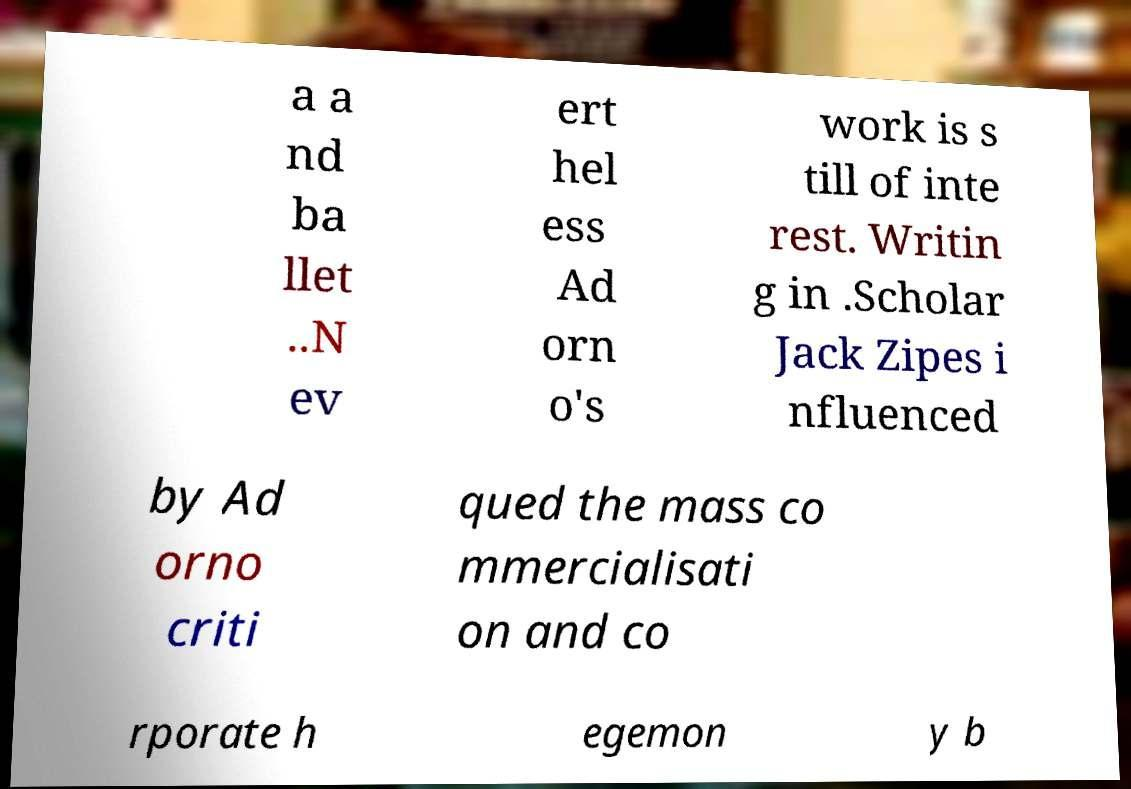Please identify and transcribe the text found in this image. a a nd ba llet ..N ev ert hel ess Ad orn o's work is s till of inte rest. Writin g in .Scholar Jack Zipes i nfluenced by Ad orno criti qued the mass co mmercialisati on and co rporate h egemon y b 